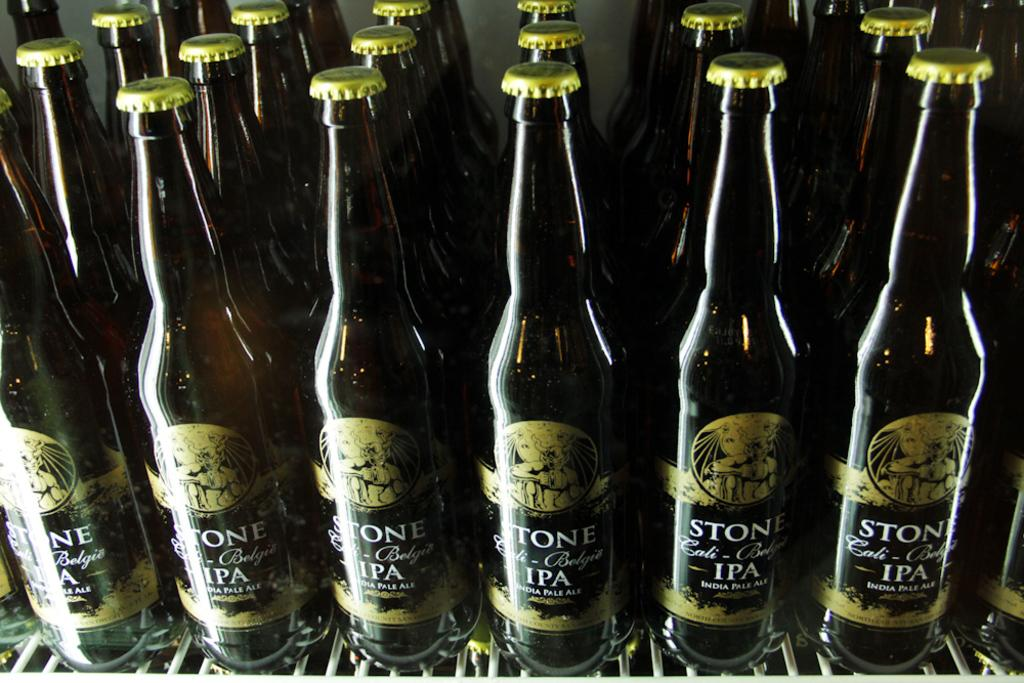Provide a one-sentence caption for the provided image. The shelf is full of Stone IPA beer. 